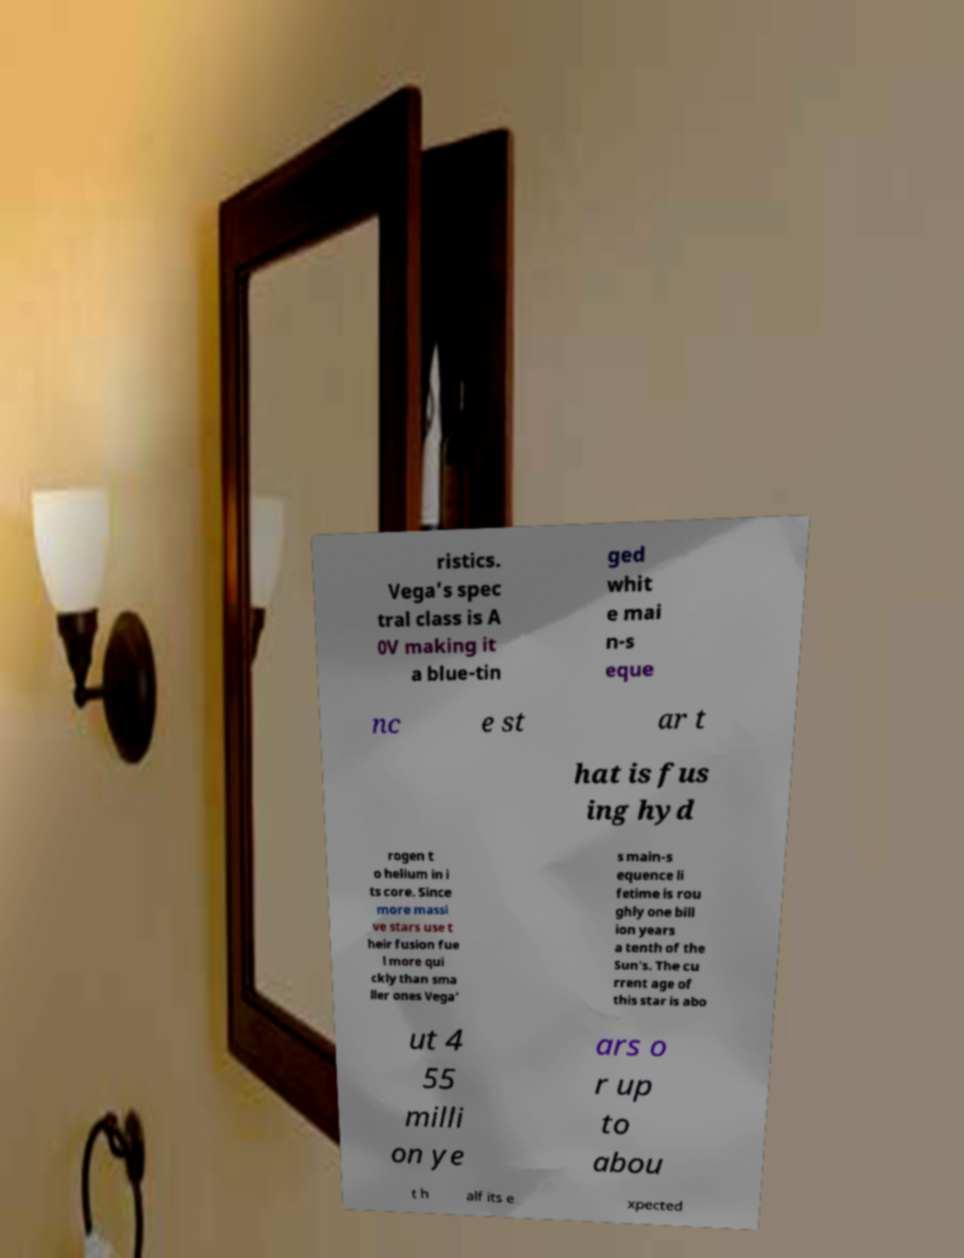I need the written content from this picture converted into text. Can you do that? ristics. Vega's spec tral class is A 0V making it a blue-tin ged whit e mai n-s eque nc e st ar t hat is fus ing hyd rogen t o helium in i ts core. Since more massi ve stars use t heir fusion fue l more qui ckly than sma ller ones Vega' s main-s equence li fetime is rou ghly one bill ion years a tenth of the Sun's. The cu rrent age of this star is abo ut 4 55 milli on ye ars o r up to abou t h alf its e xpected 